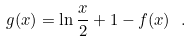<formula> <loc_0><loc_0><loc_500><loc_500>g ( x ) = \ln \frac { x } { 2 } + 1 - f ( x ) \ .</formula> 